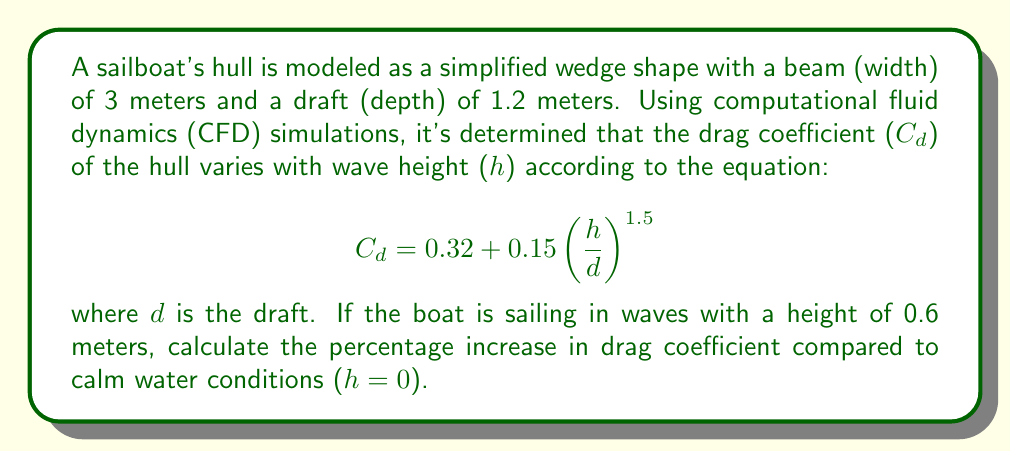Can you solve this math problem? Let's approach this step-by-step:

1) First, we need to calculate the drag coefficient in calm water (h = 0):
   $$C_{d,calm} = 0.32 + 0.15\left(\frac{0}{1.2}\right)^{1.5} = 0.32$$

2) Now, let's calculate the drag coefficient with 0.6m waves:
   $$C_{d,waves} = 0.32 + 0.15\left(\frac{0.6}{1.2}\right)^{1.5}$$
   $$= 0.32 + 0.15(0.5)^{1.5}$$
   $$= 0.32 + 0.15 \cdot 0.3535$$
   $$= 0.32 + 0.053025$$
   $$= 0.373025$$

3) To calculate the percentage increase, we use the formula:
   $$\text{Percentage Increase} = \frac{C_{d,waves} - C_{d,calm}}{C_{d,calm}} \cdot 100\%$$

4) Plugging in our values:
   $$\text{Percentage Increase} = \frac{0.373025 - 0.32}{0.32} \cdot 100\%$$
   $$= \frac{0.053025}{0.32} \cdot 100\%$$
   $$= 0.1657031 \cdot 100\%$$
   $$= 16.57\%$$

Therefore, the drag coefficient increases by approximately 16.57% in 0.6m waves compared to calm water conditions.
Answer: 16.57% 